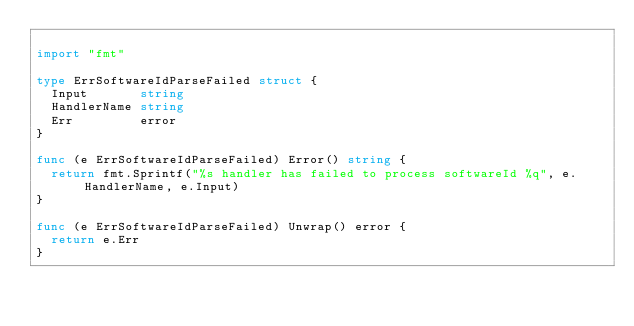<code> <loc_0><loc_0><loc_500><loc_500><_Go_>
import "fmt"

type ErrSoftwareIdParseFailed struct {
	Input       string
	HandlerName string
	Err         error
}

func (e ErrSoftwareIdParseFailed) Error() string {
	return fmt.Sprintf("%s handler has failed to process softwareId %q", e.HandlerName, e.Input)
}

func (e ErrSoftwareIdParseFailed) Unwrap() error {
	return e.Err
}
</code> 